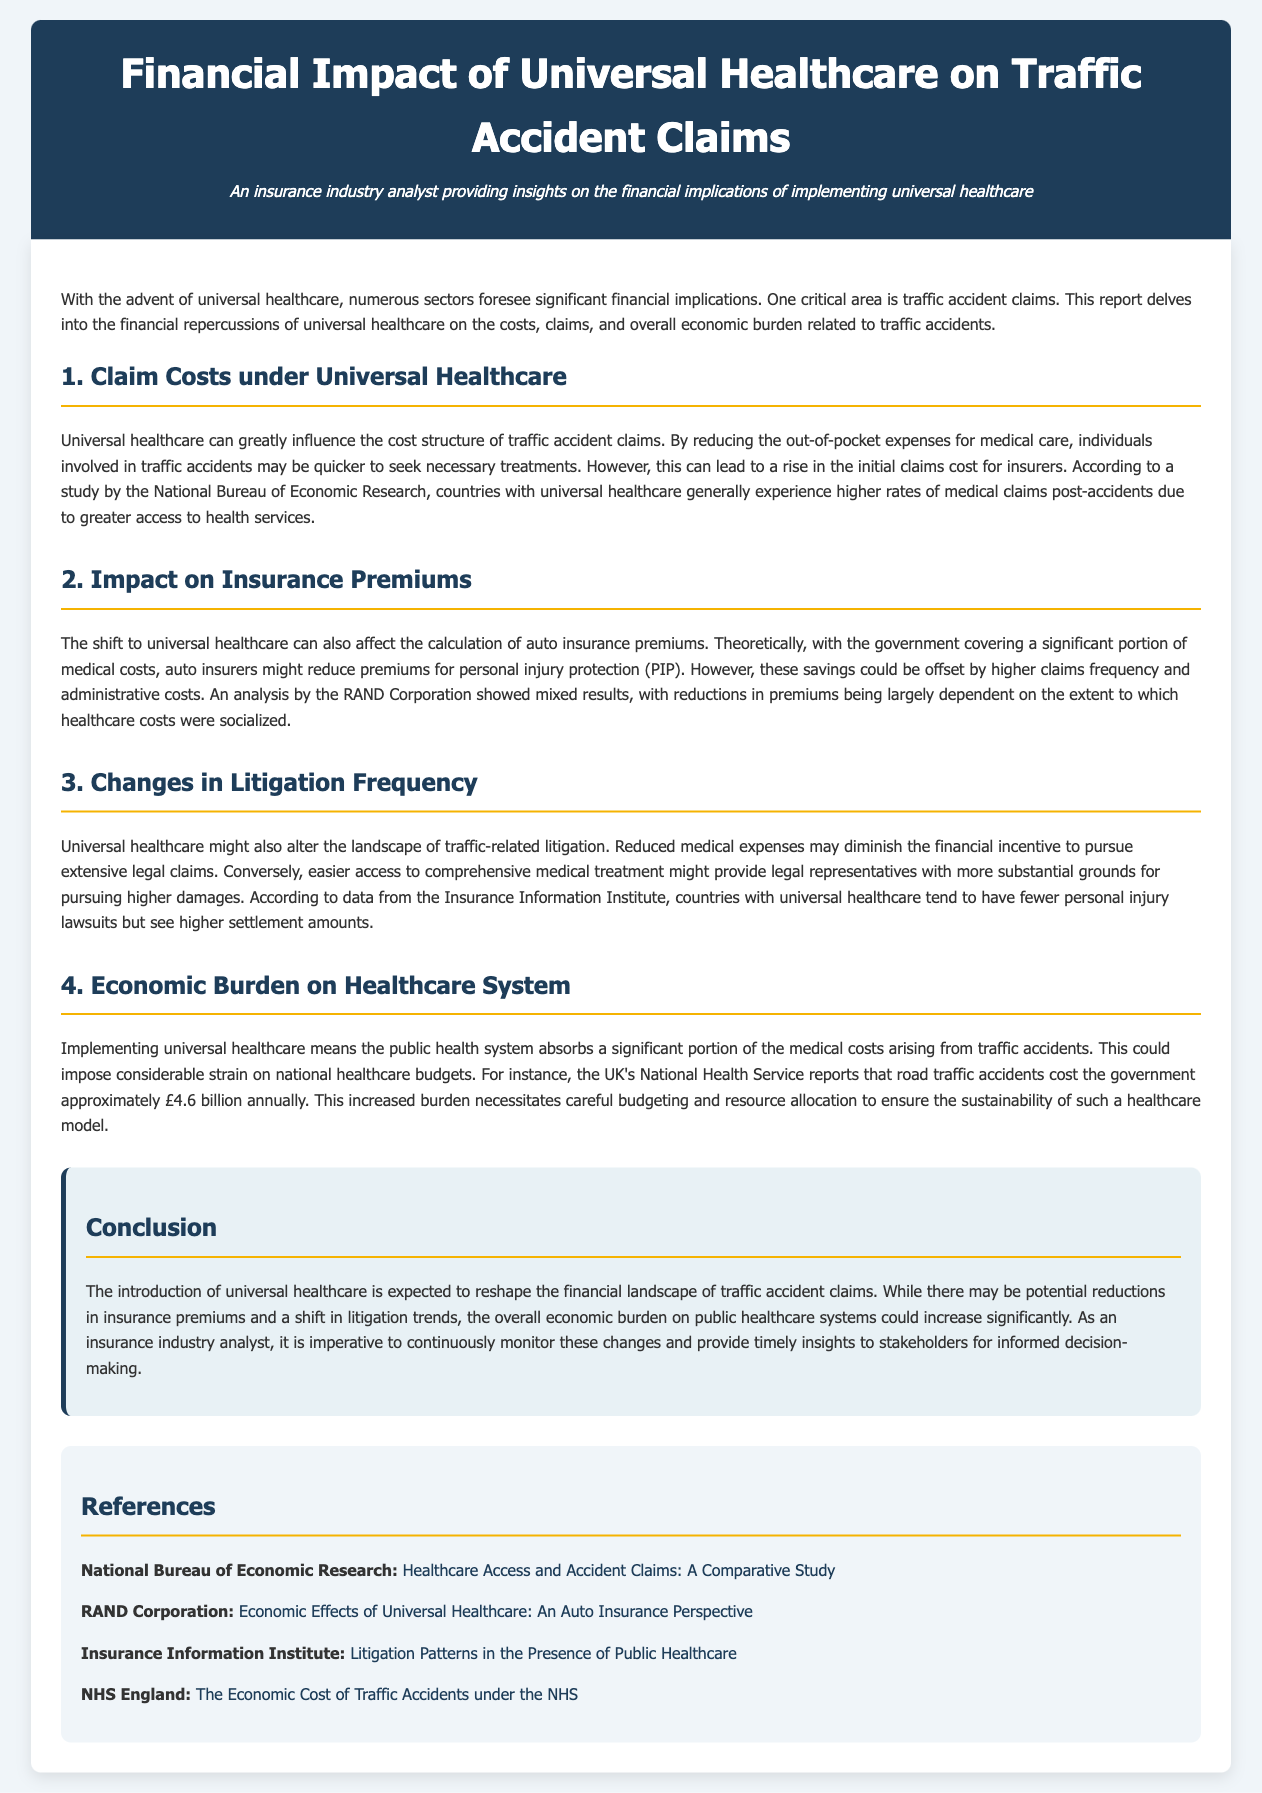What is the title of the report? The title of the report, as indicated prominently, is "Financial Impact of Universal Healthcare on Traffic Accident Claims."
Answer: Financial Impact of Universal Healthcare on Traffic Accident Claims Who authored the report? The author is identified in the header section stating their role as "An insurance industry analyst providing insights on the financial implications of implementing universal healthcare."
Answer: An insurance industry analyst What is the annual cost of road traffic accidents reported by the UK's National Health Service? The report specifies that the UK's National Health Service indicates that road traffic accidents cost the government approximately £4.6 billion annually.
Answer: £4.6 billion What impact does universal healthcare have on initial claims cost according to the report? The document states that the shift can lead to a rise in the initial claims cost for insurers due to individuals being quicker to seek necessary treatments.
Answer: Rise in initial claims cost Which organization provided an analysis showing mixed results regarding insurance premiums? The RAND Corporation is mentioned in the document as having conducted an analysis with mixed results regarding insurance premiums.
Answer: RAND Corporation What is one potential outcome of universal healthcare on litigation frequency? The report discusses that universal healthcare might alter the landscape of traffic-related litigation, potentially leading to easier access to comprehensive medical treatment providing grounds for higher damages.
Answer: Fewer personal injury lawsuits How does universal healthcare affect insurance premiums for personal injury protection? The text explains that auto insurers might reduce premiums for personal injury protection due to government covering medical costs, but these savings may be offset by higher claims frequency and administrative costs.
Answer: Could reduce premiums What is a significant economic burden mentioned in relation to universal healthcare? The report highlights that implementing universal healthcare could impose considerable strain on national healthcare budgets due to the absorption of medical costs from traffic accidents.
Answer: Strain on national healthcare budgets 